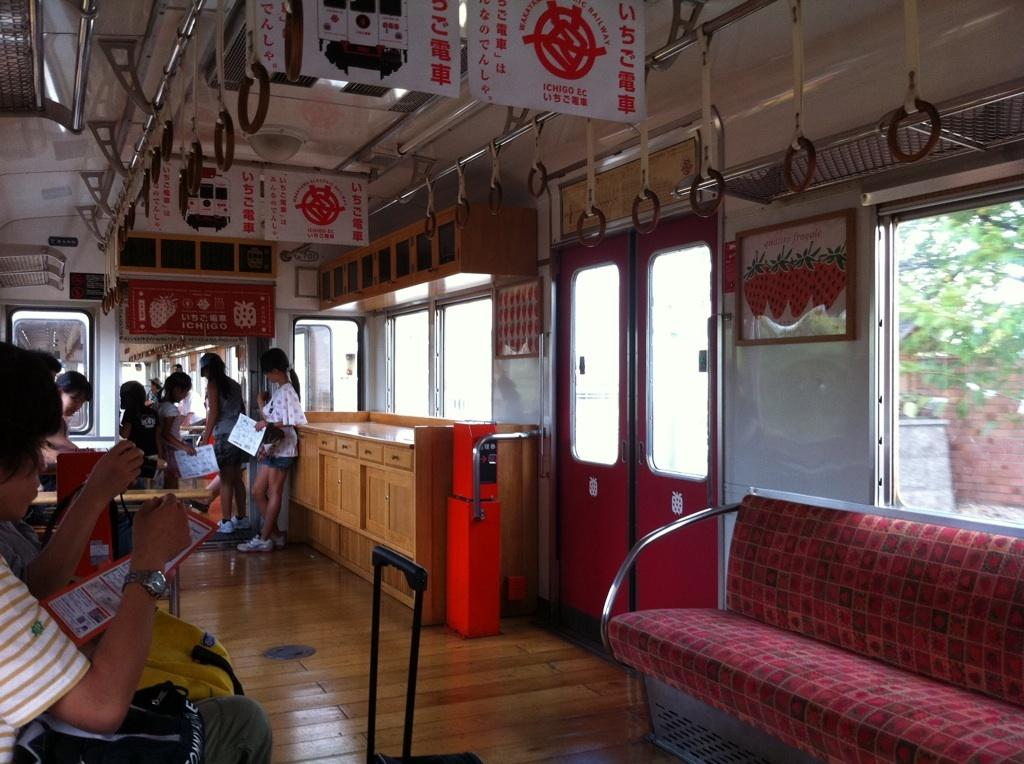How many people are in the image? There is a group of people in the image. What are some of the people in the image doing? Some persons are standing, and some are sitting. What can be seen in the background of the image? There is a tree, a window, and a hanger in the background of the image. What type of payment is being made by the kitten in the image? There is no kitten present in the image, so no payment can be made by a kitten. 